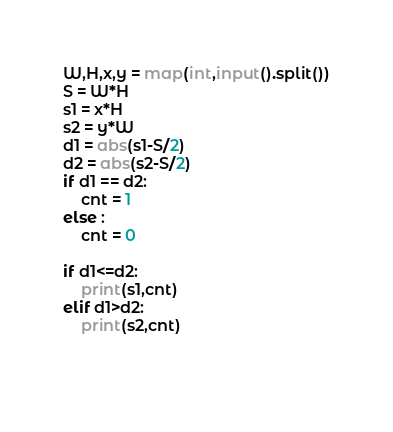<code> <loc_0><loc_0><loc_500><loc_500><_Python_>W,H,x,y = map(int,input().split())
S = W*H
s1 = x*H
s2 = y*W
d1 = abs(s1-S/2)
d2 = abs(s2-S/2)
if d1 == d2:
    cnt = 1
else :
    cnt = 0
    
if d1<=d2:
    print(s1,cnt)
elif d1>d2:
    print(s2,cnt)

    
</code> 